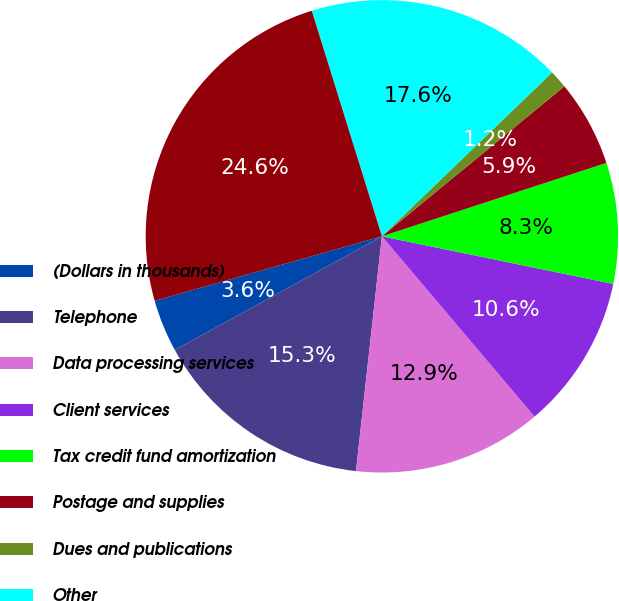Convert chart. <chart><loc_0><loc_0><loc_500><loc_500><pie_chart><fcel>(Dollars in thousands)<fcel>Telephone<fcel>Data processing services<fcel>Client services<fcel>Tax credit fund amortization<fcel>Postage and supplies<fcel>Dues and publications<fcel>Other<fcel>Total other noninterest<nl><fcel>3.59%<fcel>15.26%<fcel>12.93%<fcel>10.59%<fcel>8.26%<fcel>5.92%<fcel>1.25%<fcel>17.6%<fcel>24.6%<nl></chart> 